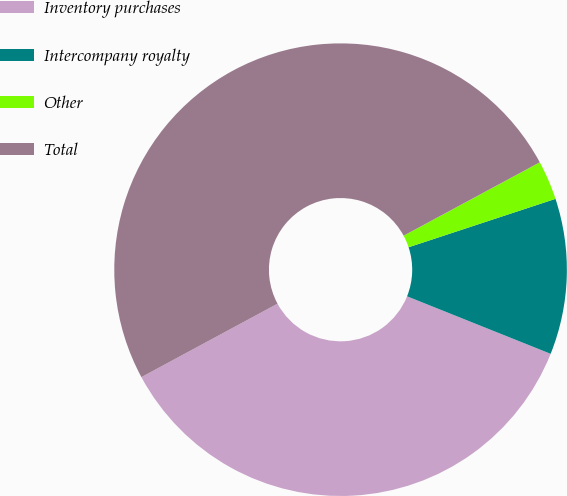<chart> <loc_0><loc_0><loc_500><loc_500><pie_chart><fcel>Inventory purchases<fcel>Intercompany royalty<fcel>Other<fcel>Total<nl><fcel>36.06%<fcel>11.13%<fcel>2.8%<fcel>50.0%<nl></chart> 